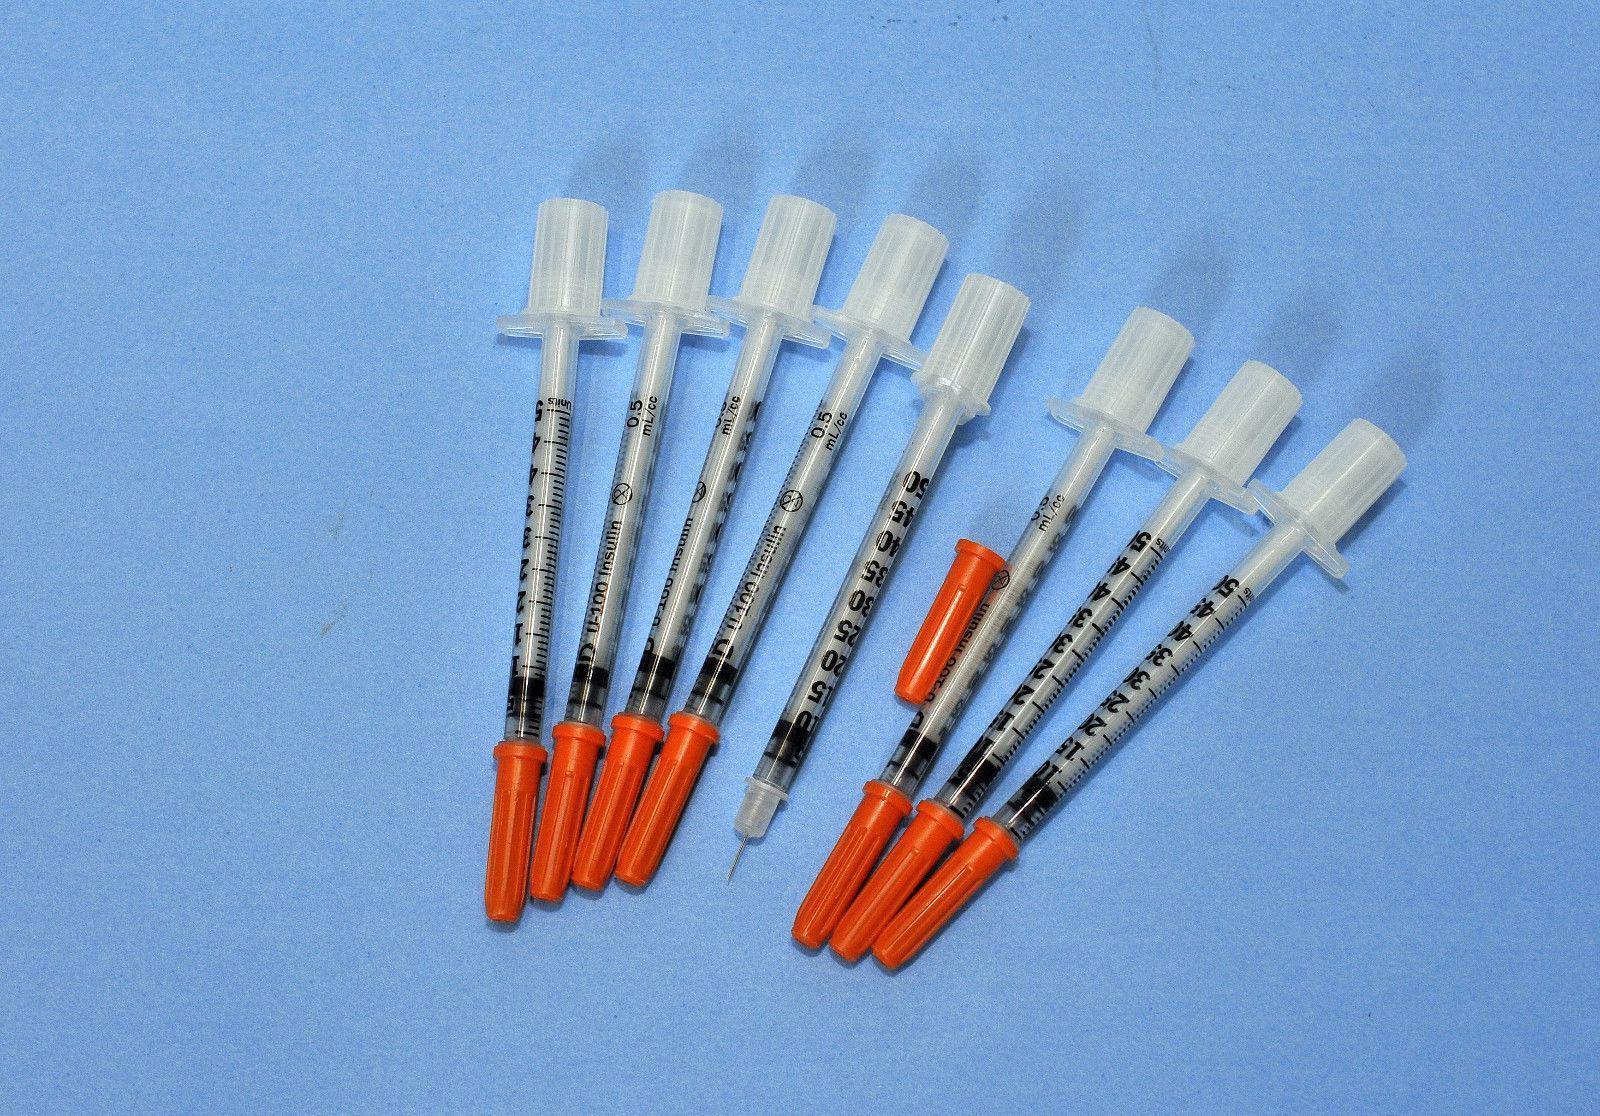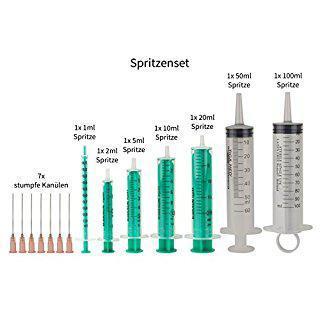The first image is the image on the left, the second image is the image on the right. For the images displayed, is the sentence "There are exactly two syringes." factually correct? Answer yes or no. No. The first image is the image on the left, the second image is the image on the right. Considering the images on both sides, is "There are no more than 2 syringes." valid? Answer yes or no. No. 